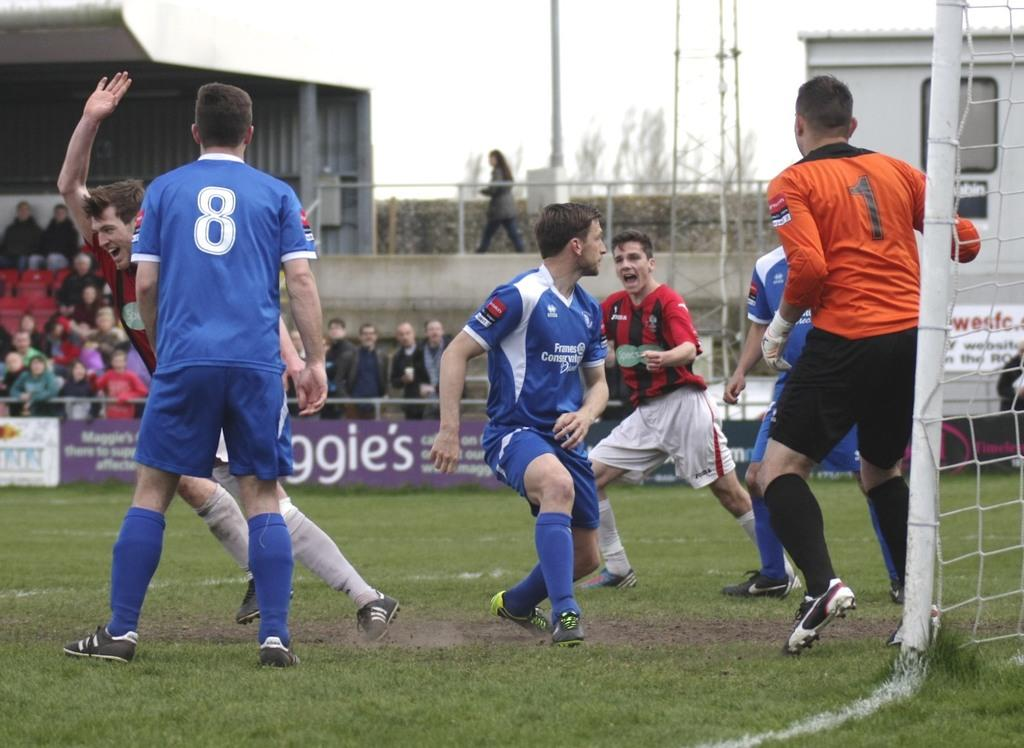<image>
Provide a brief description of the given image. Soccer player wearing number 8 standing on a soccer field. 